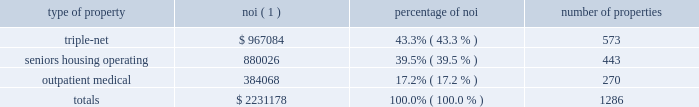Item 7 .
Management 2019s discussion and analysis of financial condition and results of operations the following discussion and analysis is based primarily on the consolidated financial statements of welltower inc .
Presented in conformity with u.s .
Generally accepted accounting principles ( 201cu.s .
Gaap 201d ) for the periods presented and should be read together with the notes thereto contained in this annual report on form 10-k .
Other important factors are identified in 201citem 1 2014 business 201d and 201citem 1a 2014 risk factors 201d above .
Executive summary company overview welltower inc .
( nyse:well ) , an s&p 500 company headquartered in toledo , ohio , is driving the transformation of health care infrastructure .
The company invests with leading seniors housing operators , post- acute providers and health systems to fund the real estate and infrastructure needed to scale innovative care delivery models and improve people 2019s wellness and overall health care experience .
Welltowertm , a real estate investment trust ( 201creit 201d ) , owns interests in properties concentrated in major , high-growth markets in the united states ( 201cu.s . 201d ) , canada and the united kingdom ( 201cu.k . 201d ) , consisting of seniors housing and post-acute communities and outpatient medical properties .
Our capital programs , when combined with comprehensive planning , development and property management services , make us a single-source solution for acquiring , planning , developing , managing , repositioning and monetizing real estate assets .
The table summarizes our consolidated portfolio for the year ended december 31 , 2017 ( dollars in thousands ) : type of property noi ( 1 ) percentage of number of properties .
( 1 ) represents consolidated noi and excludes our share of investments in unconsolidated entities .
Entities in which we have a joint venture with a minority partner are shown at 100% ( 100 % ) of the joint venture amount .
See non-gaap financial measures for additional information and reconciliation .
Business strategy our primary objectives are to protect stockholder capital and enhance stockholder value .
We seek to pay consistent cash dividends to stockholders and create opportunities to increase dividend payments to stockholders as a result of annual increases in net operating income and portfolio growth .
To meet these objectives , we invest across the full spectrum of seniors housing and health care real estate and diversify our investment portfolio by property type , relationship and geographic location .
Substantially all of our revenues are derived from operating lease rentals , resident fees/services , and interest earned on outstanding loans receivable .
These items represent our primary sources of liquidity to fund distributions and depend upon the continued ability of our obligors to make contractual rent and interest payments to us and the profitability of our operating properties .
To the extent that our obligors/partners experience operating difficulties and become unable to generate sufficient cash to make payments or operating distributions to us , there could be a material adverse impact on our consolidated results of operations , liquidity and/or financial condition .
To mitigate this risk , we monitor our investments through a variety of methods determined by the type of property .
Our asset management process for seniors housing properties generally includes review of monthly financial statements and other operating data for each property , review of obligor/ partner creditworthiness , property inspections , and review of covenant compliance relating to licensure , real estate taxes , letters of credit and other collateral .
Our internal property management division manages and monitors the outpatient medical portfolio with a comprehensive process including review of tenant relations .
What was total number of properties subject to triple-net leases and seniors housing operating housing? 
Computations: (573 + 443)
Answer: 1016.0. 